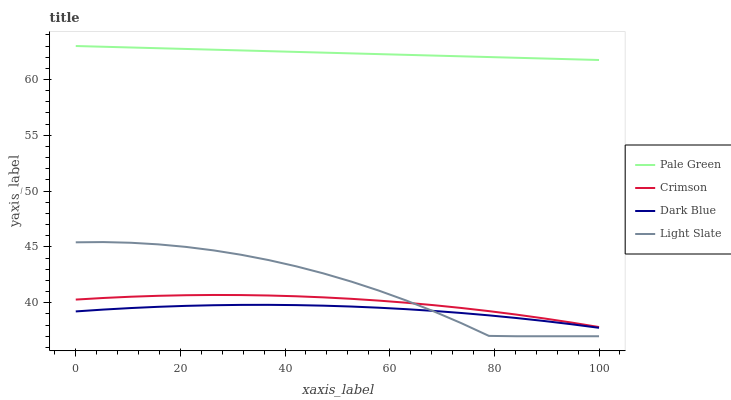Does Dark Blue have the minimum area under the curve?
Answer yes or no. Yes. Does Pale Green have the maximum area under the curve?
Answer yes or no. Yes. Does Pale Green have the minimum area under the curve?
Answer yes or no. No. Does Dark Blue have the maximum area under the curve?
Answer yes or no. No. Is Pale Green the smoothest?
Answer yes or no. Yes. Is Light Slate the roughest?
Answer yes or no. Yes. Is Dark Blue the smoothest?
Answer yes or no. No. Is Dark Blue the roughest?
Answer yes or no. No. Does Light Slate have the lowest value?
Answer yes or no. Yes. Does Dark Blue have the lowest value?
Answer yes or no. No. Does Pale Green have the highest value?
Answer yes or no. Yes. Does Dark Blue have the highest value?
Answer yes or no. No. Is Light Slate less than Pale Green?
Answer yes or no. Yes. Is Pale Green greater than Light Slate?
Answer yes or no. Yes. Does Light Slate intersect Dark Blue?
Answer yes or no. Yes. Is Light Slate less than Dark Blue?
Answer yes or no. No. Is Light Slate greater than Dark Blue?
Answer yes or no. No. Does Light Slate intersect Pale Green?
Answer yes or no. No. 